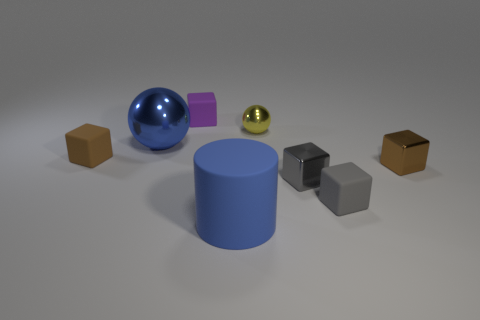Subtract all purple cubes. How many cubes are left? 4 Subtract all yellow balls. How many balls are left? 1 Subtract all spheres. How many objects are left? 6 Add 2 purple matte balls. How many objects exist? 10 Subtract 1 spheres. How many spheres are left? 1 Subtract all big rubber cubes. Subtract all yellow objects. How many objects are left? 7 Add 8 small gray metal cubes. How many small gray metal cubes are left? 9 Add 6 large objects. How many large objects exist? 8 Subtract 0 cyan balls. How many objects are left? 8 Subtract all yellow cylinders. Subtract all brown cubes. How many cylinders are left? 1 